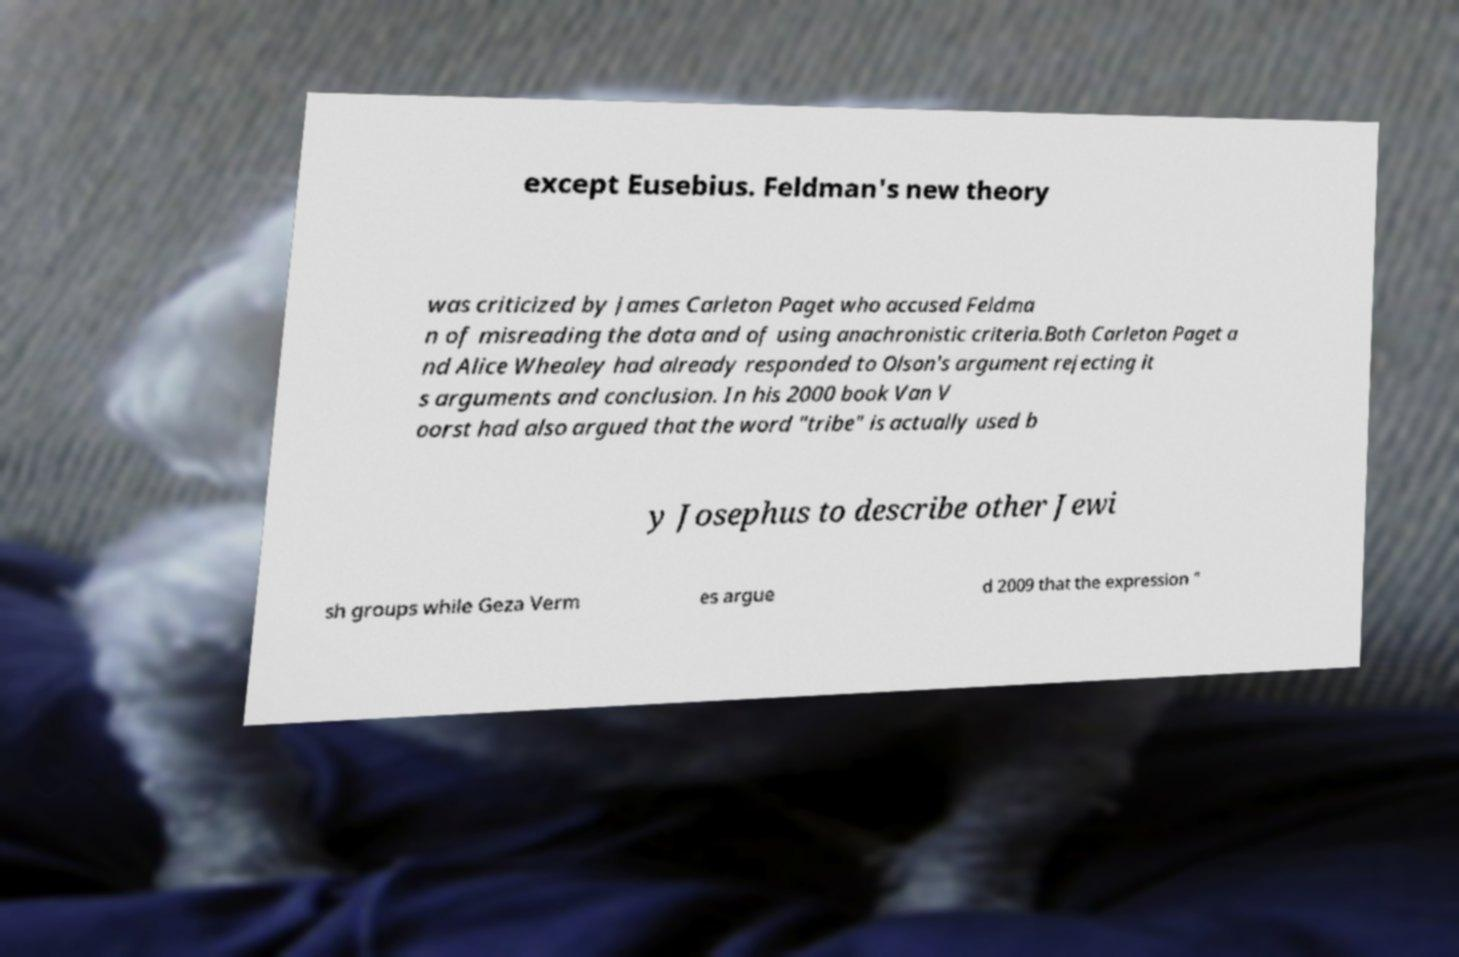Can you accurately transcribe the text from the provided image for me? except Eusebius. Feldman's new theory was criticized by James Carleton Paget who accused Feldma n of misreading the data and of using anachronistic criteria.Both Carleton Paget a nd Alice Whealey had already responded to Olson's argument rejecting it s arguments and conclusion. In his 2000 book Van V oorst had also argued that the word "tribe" is actually used b y Josephus to describe other Jewi sh groups while Geza Verm es argue d 2009 that the expression " 